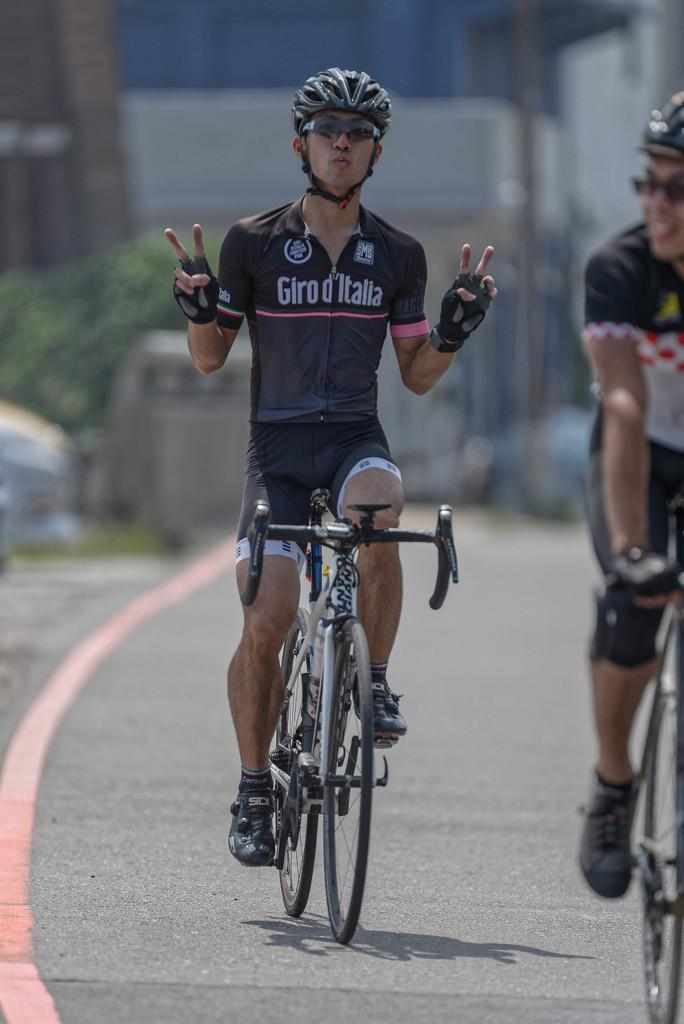What type of protective gear is the person wearing in the image? The person is wearing a helmet, goggles, and gloves in the image. What is the person sitting on in the image? The person is sitting on a cycle. Are there any other people on cycles in the image? Yes, there is another person on a cycle in the image. How would you describe the background of the image? The background of the image is blurred. What type of weather can be seen in the image? The provided facts do not mention any weather conditions, so it cannot be determined from the image. 